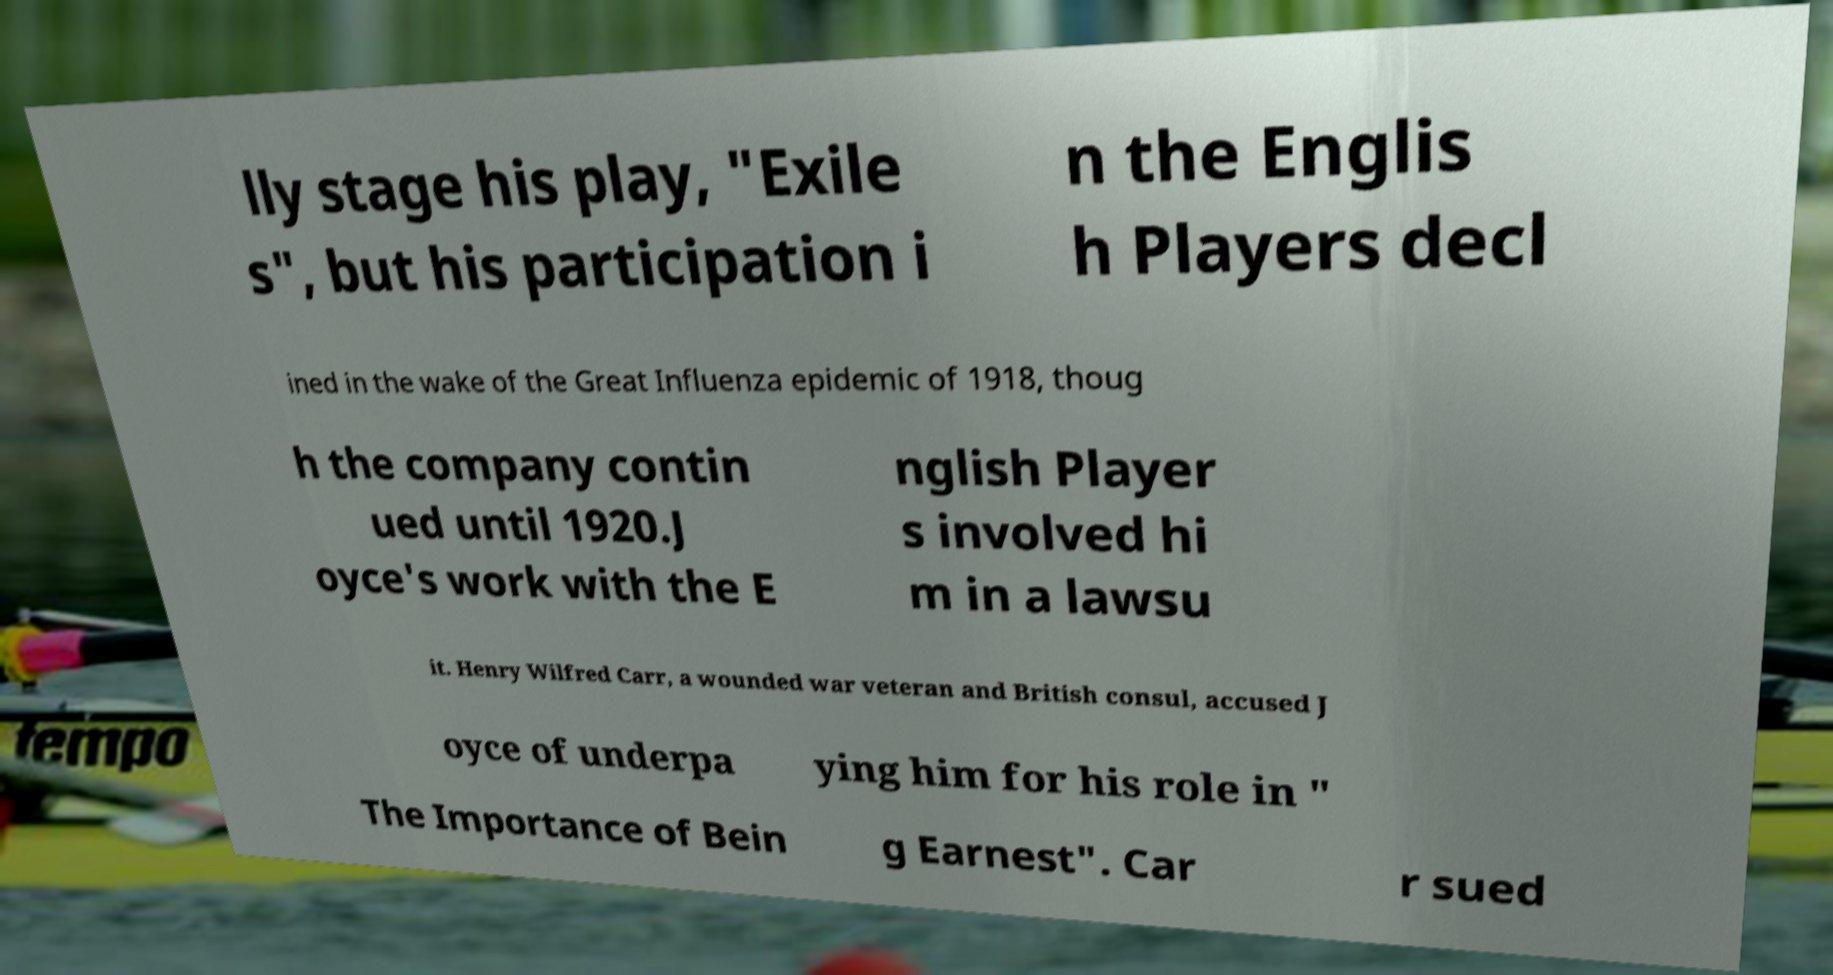There's text embedded in this image that I need extracted. Can you transcribe it verbatim? lly stage his play, "Exile s", but his participation i n the Englis h Players decl ined in the wake of the Great Influenza epidemic of 1918, thoug h the company contin ued until 1920.J oyce's work with the E nglish Player s involved hi m in a lawsu it. Henry Wilfred Carr, a wounded war veteran and British consul, accused J oyce of underpa ying him for his role in " The Importance of Bein g Earnest". Car r sued 